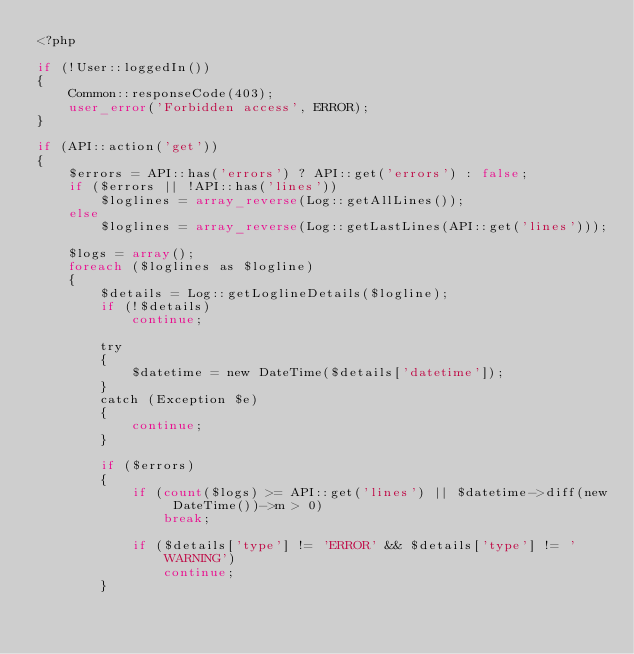Convert code to text. <code><loc_0><loc_0><loc_500><loc_500><_PHP_><?php

if (!User::loggedIn())
{
	Common::responseCode(403);
	user_error('Forbidden access', ERROR);
}

if (API::action('get'))
{
	$errors = API::has('errors') ? API::get('errors') : false;
	if ($errors || !API::has('lines'))
		$loglines = array_reverse(Log::getAllLines());
	else
		$loglines = array_reverse(Log::getLastLines(API::get('lines')));

	$logs = array();
	foreach ($loglines as $logline)
	{
		$details = Log::getLoglineDetails($logline);
		if (!$details)
			continue;

		try
		{
			$datetime = new DateTime($details['datetime']);
		}
		catch (Exception $e)
		{
			continue;
		}

		if ($errors)
		{
			if (count($logs) >= API::get('lines') || $datetime->diff(new DateTime())->m > 0)
				break;

			if ($details['type'] != 'ERROR' && $details['type'] != 'WARNING')
				continue;
		}
</code> 